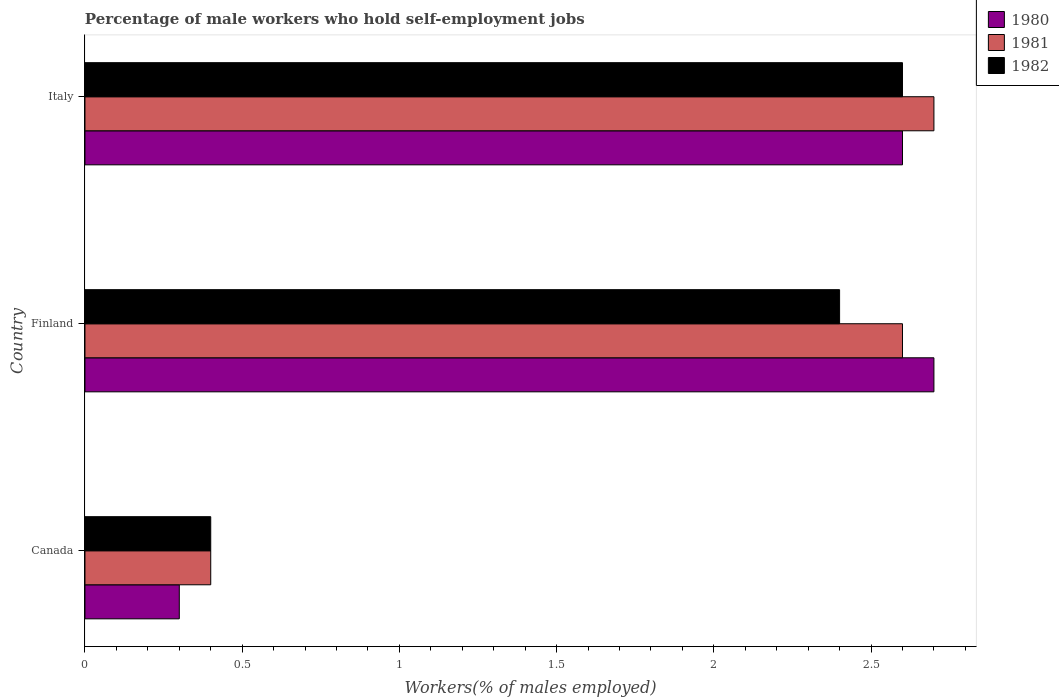How many different coloured bars are there?
Offer a very short reply. 3. Are the number of bars per tick equal to the number of legend labels?
Your answer should be very brief. Yes. How many bars are there on the 2nd tick from the bottom?
Make the answer very short. 3. In how many cases, is the number of bars for a given country not equal to the number of legend labels?
Keep it short and to the point. 0. What is the percentage of self-employed male workers in 1980 in Finland?
Make the answer very short. 2.7. Across all countries, what is the maximum percentage of self-employed male workers in 1982?
Your answer should be very brief. 2.6. Across all countries, what is the minimum percentage of self-employed male workers in 1980?
Your response must be concise. 0.3. What is the total percentage of self-employed male workers in 1981 in the graph?
Ensure brevity in your answer.  5.7. What is the difference between the percentage of self-employed male workers in 1980 in Finland and that in Italy?
Offer a terse response. 0.1. What is the difference between the percentage of self-employed male workers in 1982 in Italy and the percentage of self-employed male workers in 1981 in Canada?
Provide a succinct answer. 2.2. What is the average percentage of self-employed male workers in 1980 per country?
Give a very brief answer. 1.87. In how many countries, is the percentage of self-employed male workers in 1980 greater than 2.6 %?
Your response must be concise. 1. What is the ratio of the percentage of self-employed male workers in 1981 in Canada to that in Finland?
Provide a succinct answer. 0.15. Is the percentage of self-employed male workers in 1980 in Canada less than that in Italy?
Your response must be concise. Yes. Is the difference between the percentage of self-employed male workers in 1982 in Canada and Italy greater than the difference between the percentage of self-employed male workers in 1981 in Canada and Italy?
Your answer should be very brief. Yes. What is the difference between the highest and the second highest percentage of self-employed male workers in 1982?
Your answer should be compact. 0.2. What is the difference between the highest and the lowest percentage of self-employed male workers in 1981?
Offer a terse response. 2.3. Is the sum of the percentage of self-employed male workers in 1980 in Canada and Finland greater than the maximum percentage of self-employed male workers in 1982 across all countries?
Provide a short and direct response. Yes. What does the 3rd bar from the top in Finland represents?
Provide a succinct answer. 1980. What does the 3rd bar from the bottom in Italy represents?
Ensure brevity in your answer.  1982. How many bars are there?
Give a very brief answer. 9. Are all the bars in the graph horizontal?
Your answer should be very brief. Yes. What is the difference between two consecutive major ticks on the X-axis?
Provide a short and direct response. 0.5. Does the graph contain grids?
Provide a short and direct response. No. How many legend labels are there?
Your response must be concise. 3. What is the title of the graph?
Your answer should be compact. Percentage of male workers who hold self-employment jobs. What is the label or title of the X-axis?
Make the answer very short. Workers(% of males employed). What is the label or title of the Y-axis?
Ensure brevity in your answer.  Country. What is the Workers(% of males employed) of 1980 in Canada?
Provide a short and direct response. 0.3. What is the Workers(% of males employed) in 1981 in Canada?
Your answer should be compact. 0.4. What is the Workers(% of males employed) in 1982 in Canada?
Your answer should be very brief. 0.4. What is the Workers(% of males employed) of 1980 in Finland?
Keep it short and to the point. 2.7. What is the Workers(% of males employed) in 1981 in Finland?
Make the answer very short. 2.6. What is the Workers(% of males employed) in 1982 in Finland?
Your response must be concise. 2.4. What is the Workers(% of males employed) of 1980 in Italy?
Ensure brevity in your answer.  2.6. What is the Workers(% of males employed) of 1981 in Italy?
Make the answer very short. 2.7. What is the Workers(% of males employed) in 1982 in Italy?
Give a very brief answer. 2.6. Across all countries, what is the maximum Workers(% of males employed) in 1980?
Give a very brief answer. 2.7. Across all countries, what is the maximum Workers(% of males employed) of 1981?
Make the answer very short. 2.7. Across all countries, what is the maximum Workers(% of males employed) in 1982?
Make the answer very short. 2.6. Across all countries, what is the minimum Workers(% of males employed) in 1980?
Make the answer very short. 0.3. Across all countries, what is the minimum Workers(% of males employed) of 1981?
Ensure brevity in your answer.  0.4. Across all countries, what is the minimum Workers(% of males employed) in 1982?
Your response must be concise. 0.4. What is the total Workers(% of males employed) of 1980 in the graph?
Your response must be concise. 5.6. What is the total Workers(% of males employed) in 1981 in the graph?
Offer a terse response. 5.7. What is the total Workers(% of males employed) of 1982 in the graph?
Make the answer very short. 5.4. What is the difference between the Workers(% of males employed) of 1980 in Canada and that in Finland?
Ensure brevity in your answer.  -2.4. What is the difference between the Workers(% of males employed) of 1981 in Canada and that in Italy?
Ensure brevity in your answer.  -2.3. What is the difference between the Workers(% of males employed) of 1982 in Canada and that in Italy?
Make the answer very short. -2.2. What is the difference between the Workers(% of males employed) of 1981 in Finland and that in Italy?
Offer a terse response. -0.1. What is the difference between the Workers(% of males employed) in 1982 in Finland and that in Italy?
Your answer should be compact. -0.2. What is the difference between the Workers(% of males employed) of 1980 in Canada and the Workers(% of males employed) of 1981 in Italy?
Ensure brevity in your answer.  -2.4. What is the difference between the Workers(% of males employed) in 1980 in Finland and the Workers(% of males employed) in 1981 in Italy?
Provide a short and direct response. 0. What is the difference between the Workers(% of males employed) in 1980 in Finland and the Workers(% of males employed) in 1982 in Italy?
Provide a short and direct response. 0.1. What is the difference between the Workers(% of males employed) of 1981 in Finland and the Workers(% of males employed) of 1982 in Italy?
Make the answer very short. 0. What is the average Workers(% of males employed) in 1980 per country?
Give a very brief answer. 1.87. What is the difference between the Workers(% of males employed) in 1980 and Workers(% of males employed) in 1982 in Canada?
Provide a short and direct response. -0.1. What is the difference between the Workers(% of males employed) in 1981 and Workers(% of males employed) in 1982 in Canada?
Ensure brevity in your answer.  0. What is the difference between the Workers(% of males employed) in 1980 and Workers(% of males employed) in 1981 in Finland?
Keep it short and to the point. 0.1. What is the difference between the Workers(% of males employed) of 1980 and Workers(% of males employed) of 1982 in Finland?
Offer a terse response. 0.3. What is the difference between the Workers(% of males employed) of 1980 and Workers(% of males employed) of 1982 in Italy?
Offer a very short reply. 0. What is the difference between the Workers(% of males employed) of 1981 and Workers(% of males employed) of 1982 in Italy?
Offer a terse response. 0.1. What is the ratio of the Workers(% of males employed) in 1980 in Canada to that in Finland?
Your answer should be very brief. 0.11. What is the ratio of the Workers(% of males employed) in 1981 in Canada to that in Finland?
Offer a very short reply. 0.15. What is the ratio of the Workers(% of males employed) of 1980 in Canada to that in Italy?
Provide a succinct answer. 0.12. What is the ratio of the Workers(% of males employed) in 1981 in Canada to that in Italy?
Keep it short and to the point. 0.15. What is the ratio of the Workers(% of males employed) of 1982 in Canada to that in Italy?
Your response must be concise. 0.15. What is the ratio of the Workers(% of males employed) of 1982 in Finland to that in Italy?
Ensure brevity in your answer.  0.92. What is the difference between the highest and the second highest Workers(% of males employed) in 1980?
Your answer should be very brief. 0.1. What is the difference between the highest and the second highest Workers(% of males employed) of 1981?
Offer a very short reply. 0.1. What is the difference between the highest and the lowest Workers(% of males employed) of 1980?
Give a very brief answer. 2.4. What is the difference between the highest and the lowest Workers(% of males employed) in 1981?
Keep it short and to the point. 2.3. What is the difference between the highest and the lowest Workers(% of males employed) in 1982?
Make the answer very short. 2.2. 